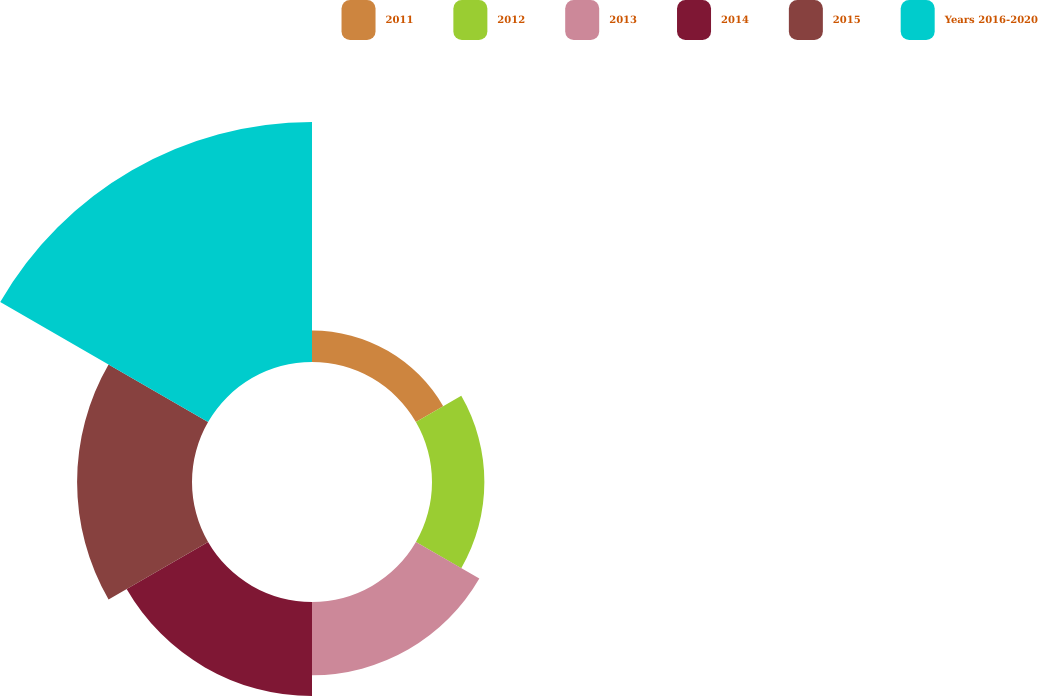<chart> <loc_0><loc_0><loc_500><loc_500><pie_chart><fcel>2011<fcel>2012<fcel>2013<fcel>2014<fcel>2015<fcel>Years 2016-2020<nl><fcel>5.2%<fcel>8.64%<fcel>12.08%<fcel>15.52%<fcel>18.96%<fcel>39.6%<nl></chart> 